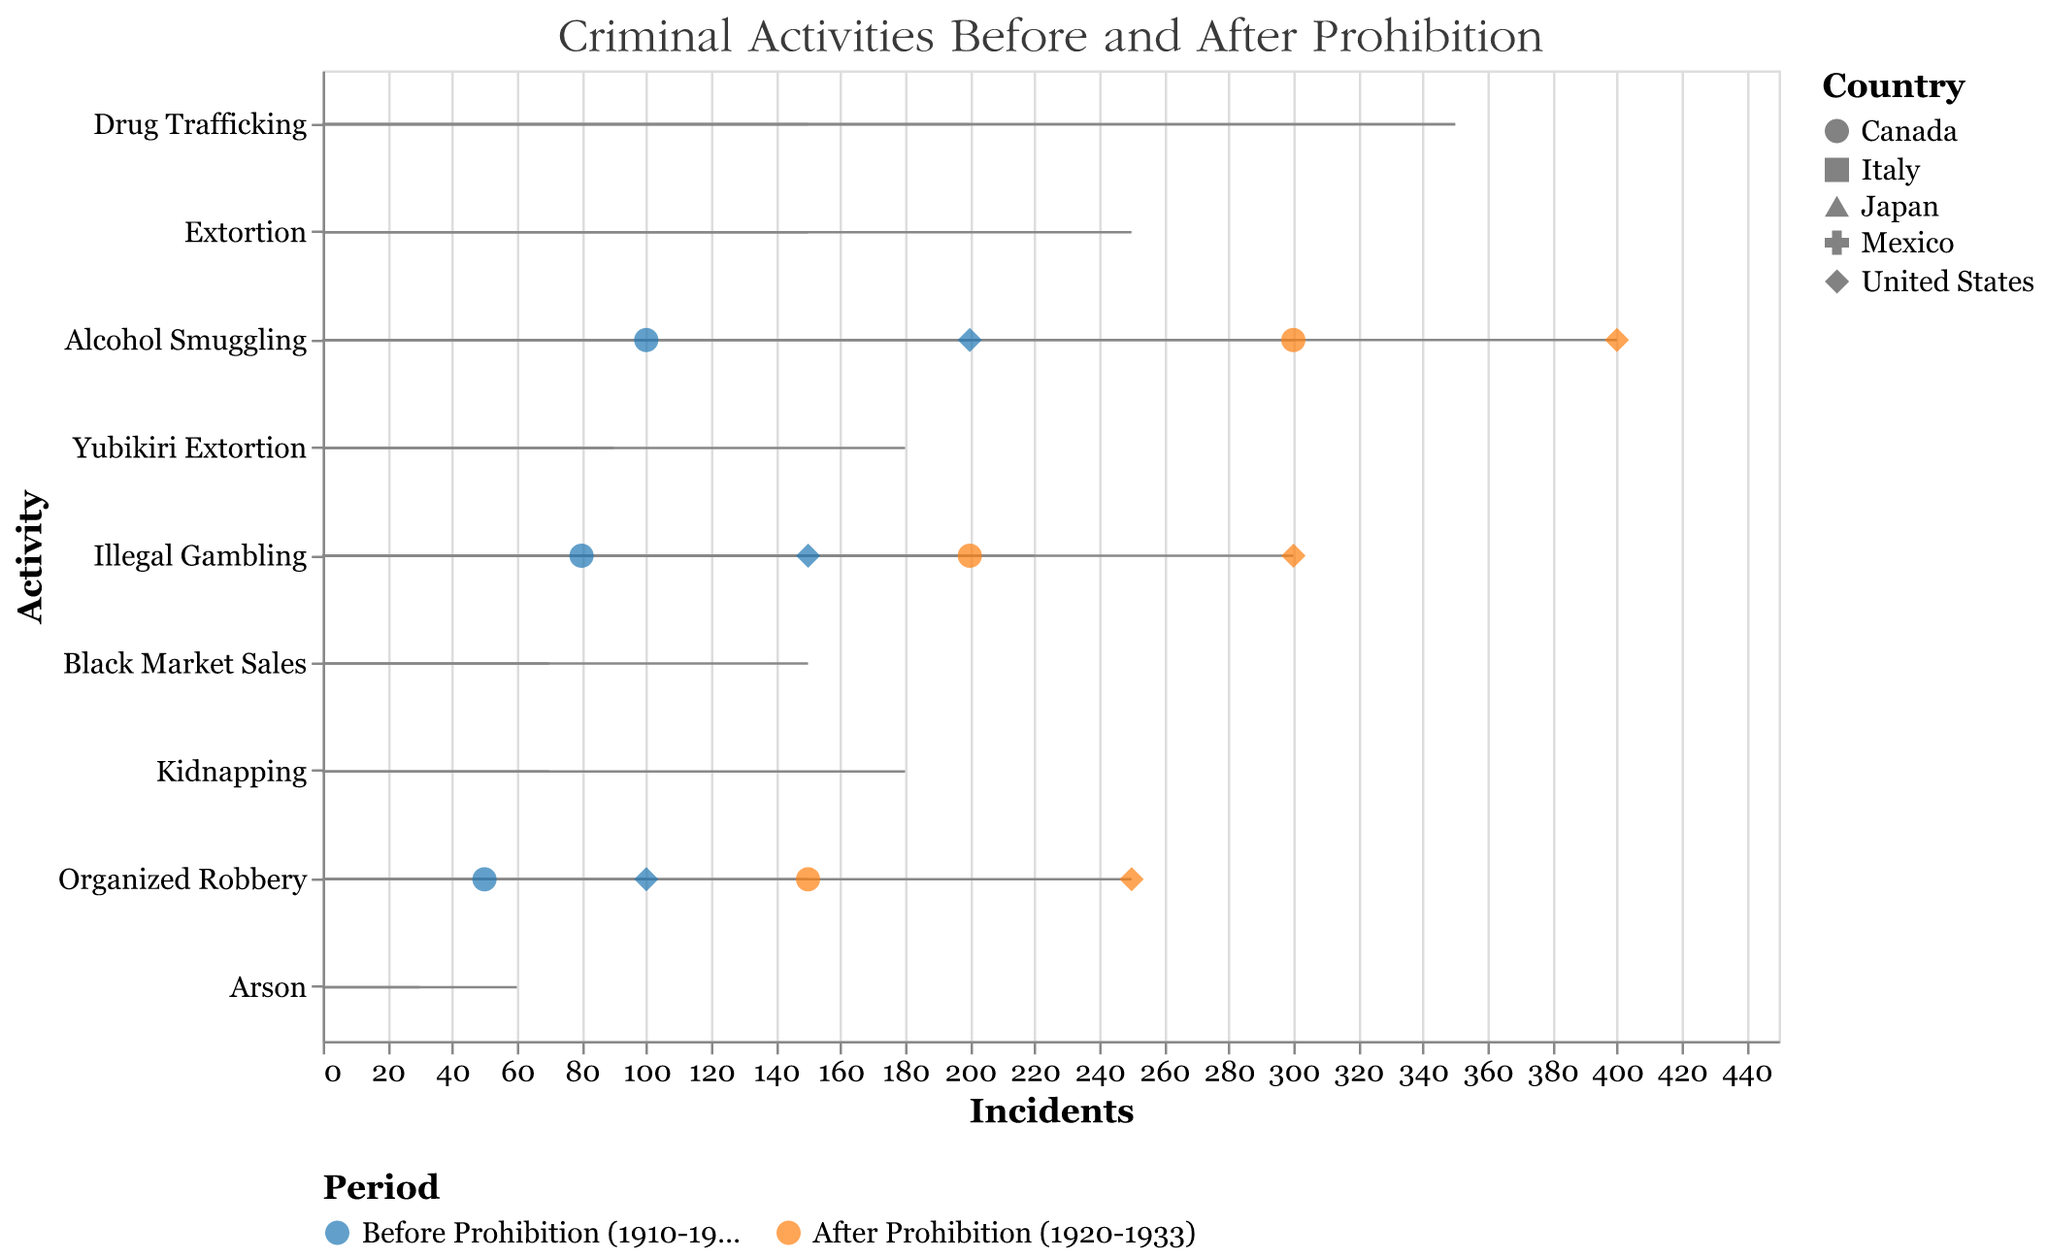What is the title of the figure? The title of the figure is usually displayed at the top of the chart. It provides an overview of what the chart is about. In this case, it reads, "Criminal Activities Before and After Prohibition."
Answer: Criminal Activities Before and After Prohibition Which country experienced the highest increase in alcohol smuggling incidents after prohibition? To find the country with the highest increase in alcohol smuggling, we compare the number of incidents before and after the prohibition for each country listed under the "Alcohol Smuggling" activity. The United States had 200 incidents before and 400 incidents after, while Canada had 100 incidents before and 300 incidents after. The increase for both countries is 200 incidents, making it a tie between the United States and Canada.
Answer: United States and Canada How many incidents of organized robbery were reported in the United States after the prohibition period? We locate the data points for organized robbery in the United States under the "After Prohibition" period. The number of incidents shown is 250.
Answer: 250 Compare the number of illegal gambling incidents in Canada before and after prohibition. First, find the data points for illegal gambling in Canada. The incidents before prohibition are 80, and after prohibition, there are 200 incidents. The difference is 200 - 80 = 120 incidents.
Answer: The number increased by 120 incidents What is the sum of drug trafficking incidents in Mexico before and after prohibition? To find the sum, we add the number of drug trafficking incidents before and after the prohibition in Mexico. That's 150 incidents before and 350 incidents after. Therefore, 150 + 350 = 500 incidents in total.
Answer: 500 Which criminal activity in Italy shows the smallest increase after prohibition? We need to compare the increase in incidents for each activity in Italy. Drug Trafficking increased from 200 to 350 (increase of 150), Extortion from 150 to 250 (increase of 100), and Illegal Gambling from 100 to 200 (increase of 100). The smallest increase is in Extortion and Illegal Gambling, which both increased by 100 incidents.
Answer: Extortion and Illegal Gambling Did the instances of arson in Japan double after prohibition? Arson incidents in Japan before prohibition are 30, and after prohibition, they are 60. Doubling the incidents means 30 x 2 = 60. Since the after prohibition value is 60, the incidents indeed doubled.
Answer: Yes How many more illegal gambling incidents were reported in the United States compared to Canada after the prohibition period? First, find the number of illegal gambling incidents in both countries after prohibition. The United States had 300 incidents, and Canada had 200. The difference is 300 - 200 = 100 incidents.
Answer: 100 more incidents 